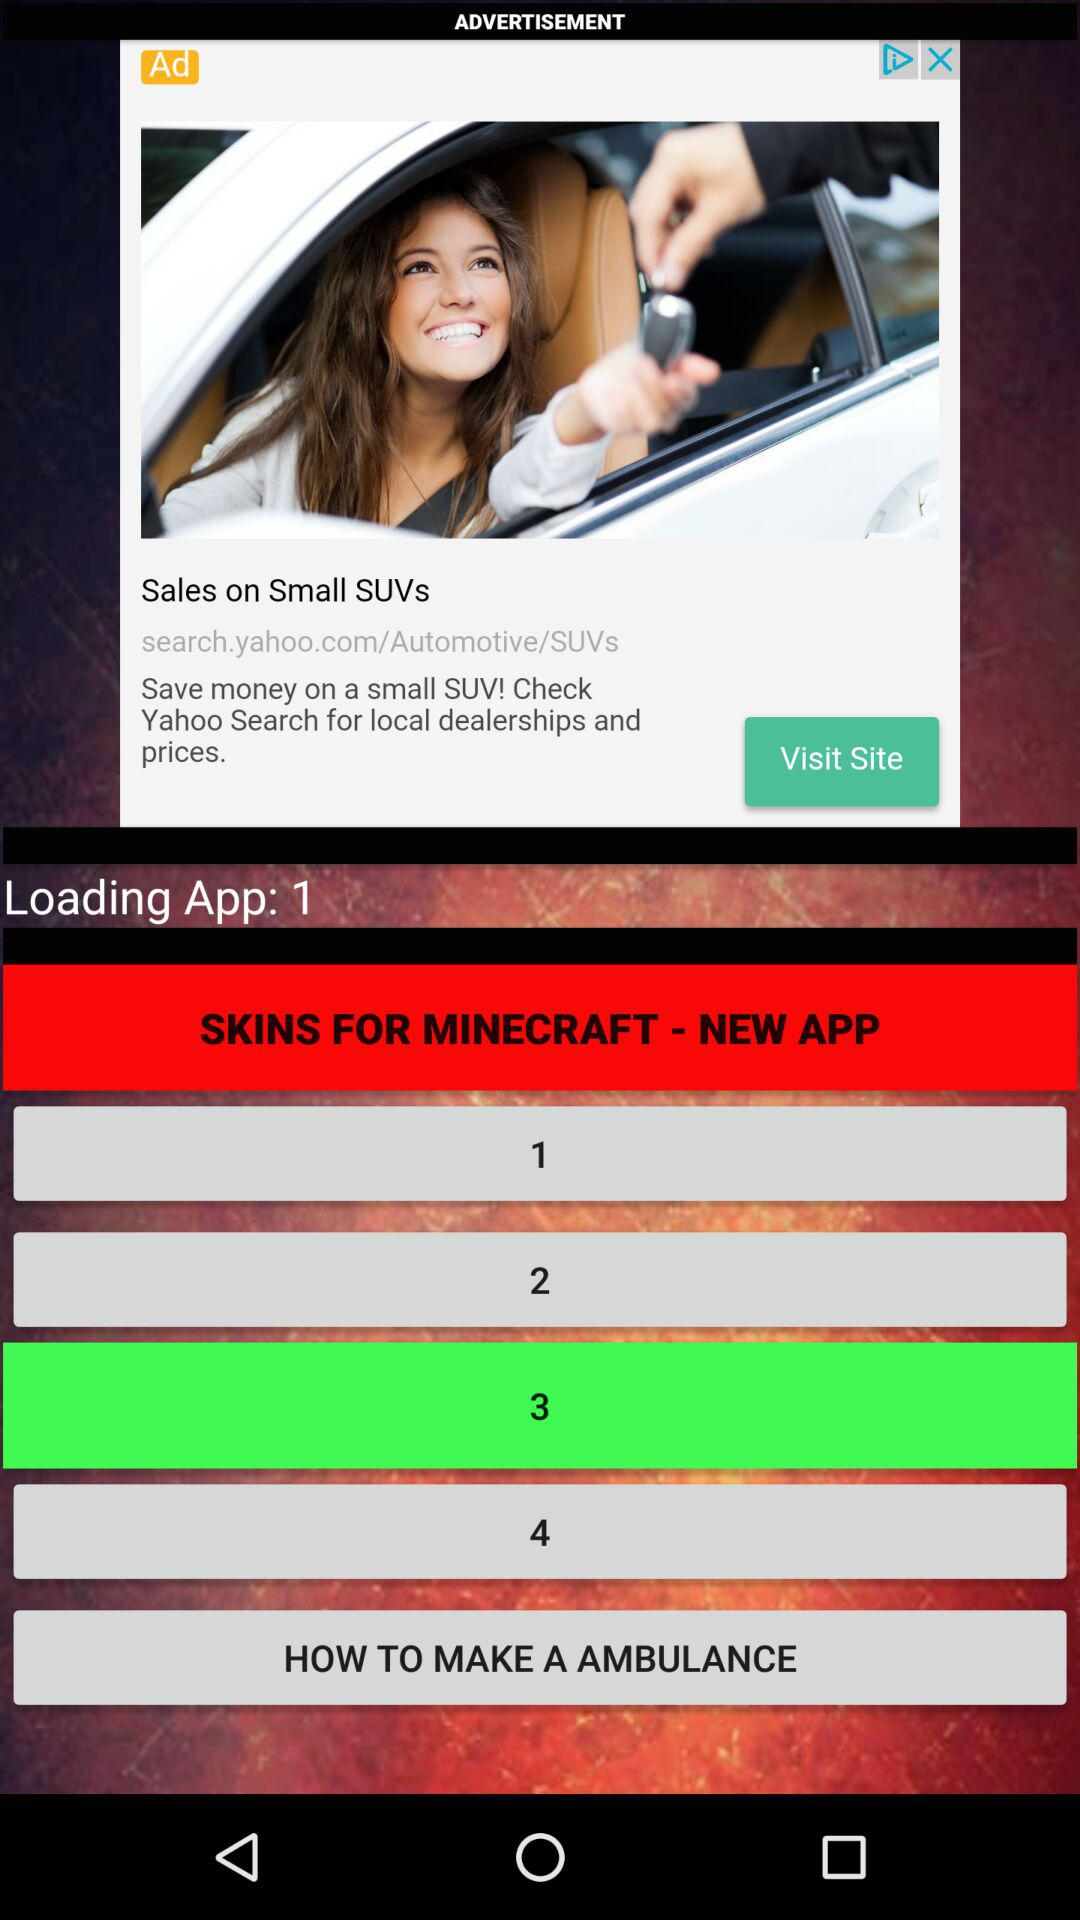Which option is selected in the new app "SKINS FOR MINECRAFT"? The selected option is "3". 